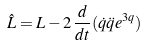<formula> <loc_0><loc_0><loc_500><loc_500>\hat { L } = L - 2 \, \frac { d } { d t } ( \dot { q } \ddot { q } e ^ { 3 q } )</formula> 